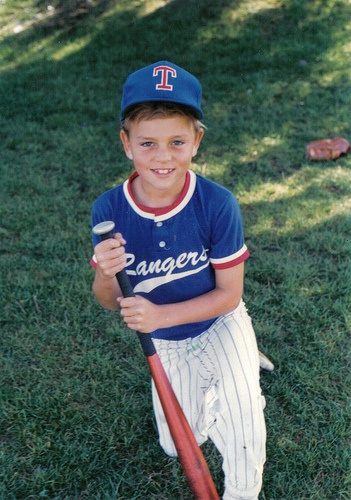Describe the objects in this image and their specific colors. I can see people in khaki, lightgray, navy, lightpink, and blue tones, baseball bat in khaki, brown, salmon, black, and navy tones, and baseball glove in khaki, brown, gray, and black tones in this image. 